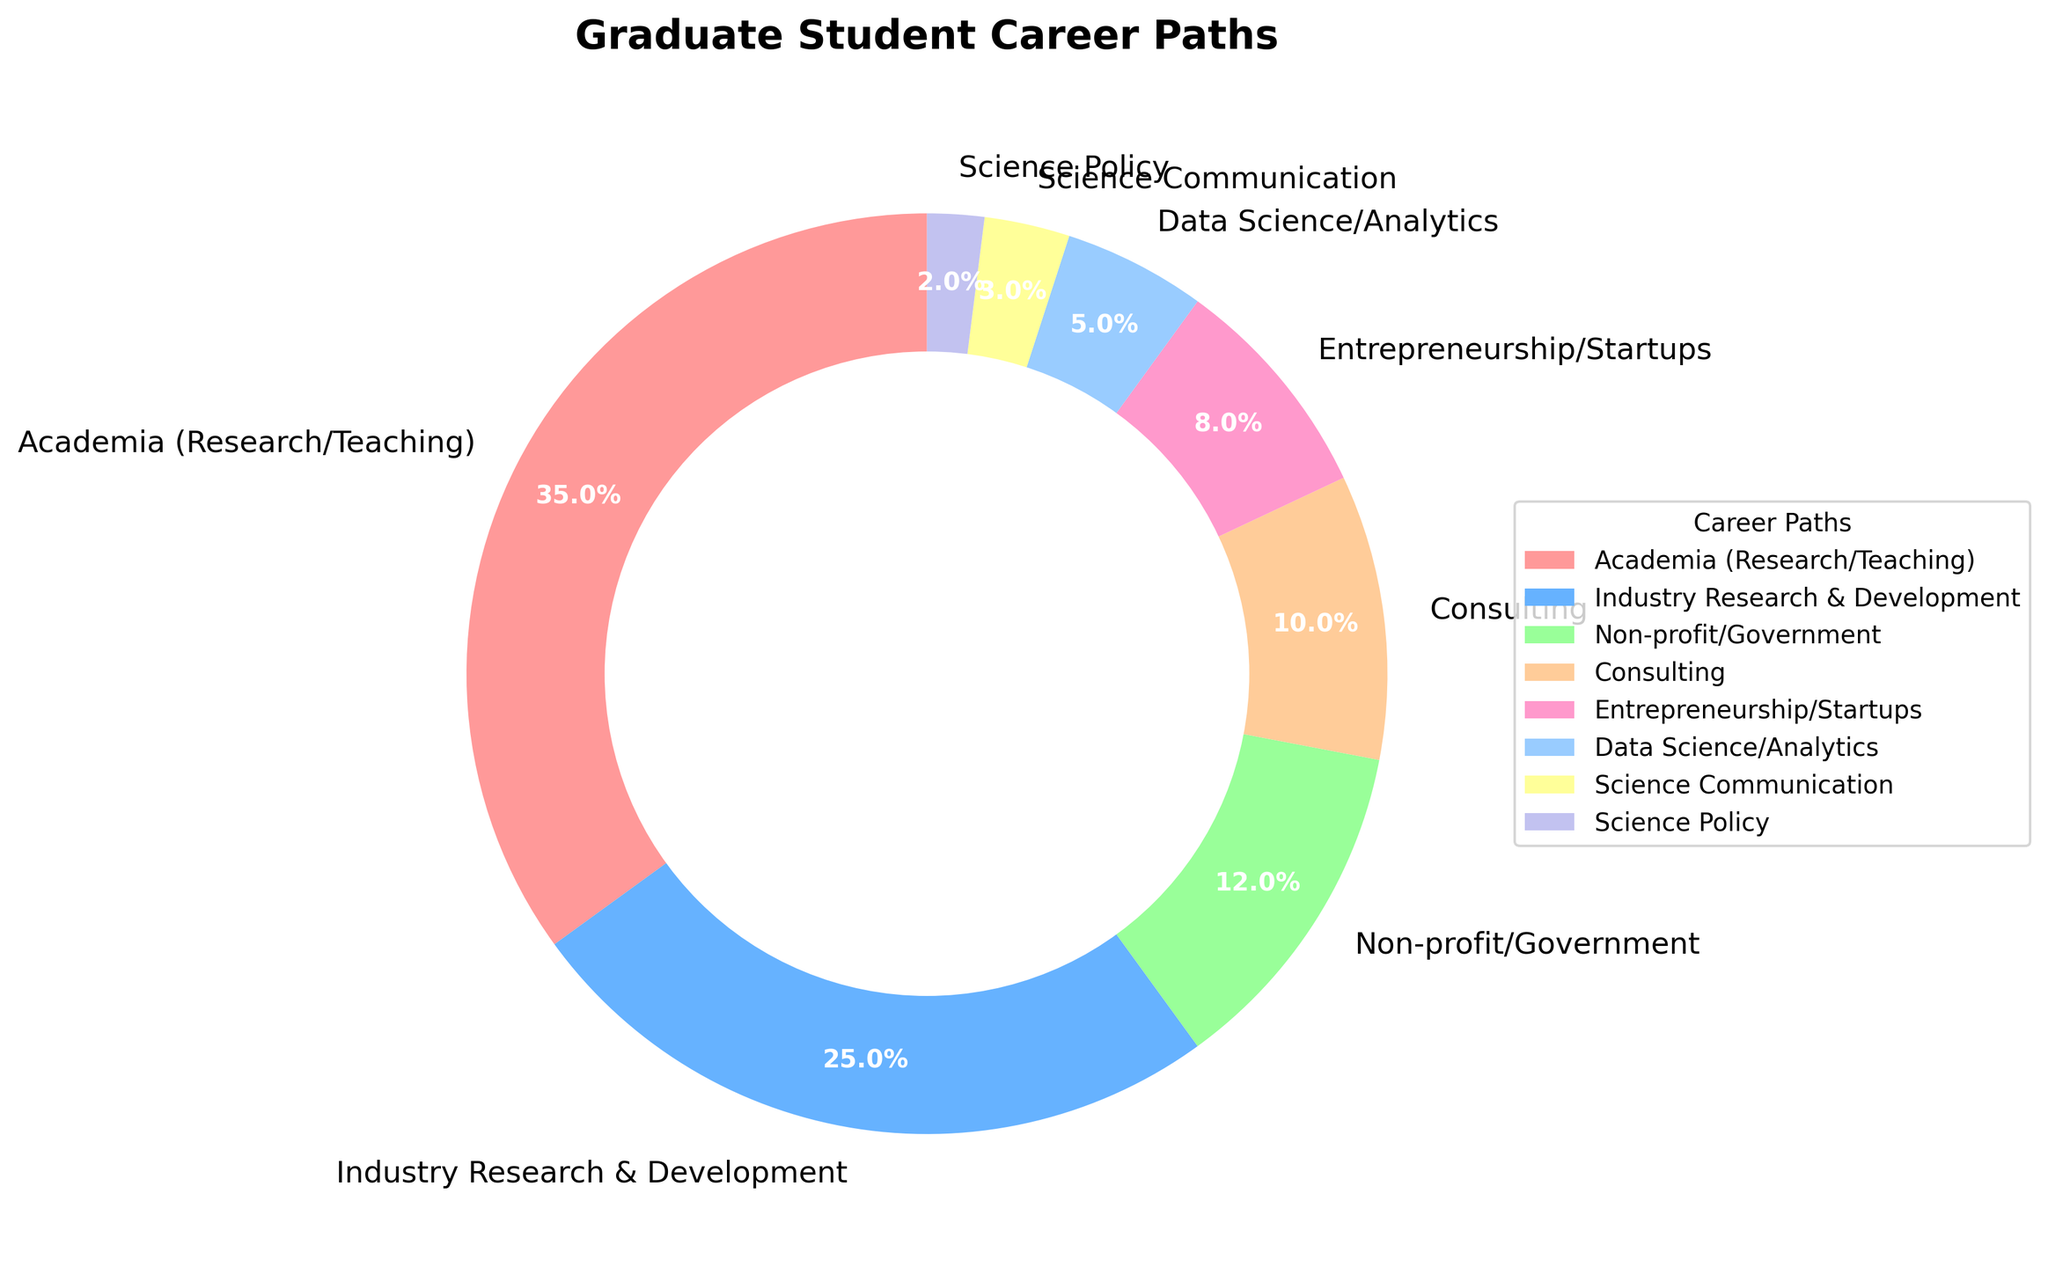What is the most common career path among graduate students? The most common career path can be found by identifying the segment with the largest percentage. The largest segment is for "Academia (Research/Teaching)" with 35%.
Answer: Academia (Research/Teaching) Which career path is the least common? The least common career path can be found by identifying the segment with the smallest percentage. The smallest segment is for "Science Policy" with 2%.
Answer: Science Policy How many percentage points more do students pursue Industry R&D compared to Data Science/Analytics? Subtract the percentage of students in Data Science/Analytics from those in Industry R&D. (25% - 5% = 20%)
Answer: 20% Are there more students in Consulting or in Non-profit/Government roles? Consulting has 10% and Non-profit/Government has 12%. Comparing these values, there are more students in Non-profit/Government roles.
Answer: Non-profit/Government What is the combined percentage of students in Entrepreneurship/Startups and Science Communication? Add the percentages for Entrepreneurship/Startups and Science Communication. (8% + 3% = 11%)
Answer: 11% How does the proportion of students in Academia (Research/Teaching) compare to that in Consulting? Academia (Research/Teaching) is 35% and Consulting is 10%. 35% is greater than 10%.
Answer: Greater What is the total percentage of students pursuing careers in Academia (Research/Teaching), Industry R&D, and Non-profit/Government? Add the percentages for these three career paths. (35% + 25% + 12% = 72%)
Answer: 72% Which career path has a percentage closest to that of Consulting? Consulting has 10%. The closest percentage is Non-profit/Government with 12%.
Answer: Non-profit/Government What proportion of students pursue career paths other than Academia (Research/Teaching) and Industry R&D? Subtract the sum of percentages for Academia (Research/Teaching) and Industry R&D from 100%. (100% - 35% - 25% = 40%)
Answer: 40% Which career paths are represented by shades of blue in the plot? Shades of blue are used for "Industry Research & Development" and "Data Science/Analytics." Identify these segments from the plot.
Answer: Industry Research & Development, Data Science/Analytics 